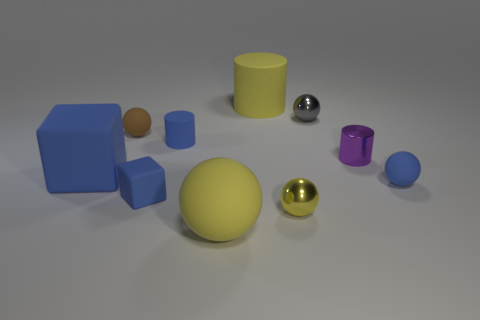How do the shadows in the image help to understand the light source? The shadows in the image are cast to the left of the objects, indicating that the light source is situated to the right, potentially above the objects. The length and direction of the shadows also suggest that the light source is not directly overhead, but at an angle. 